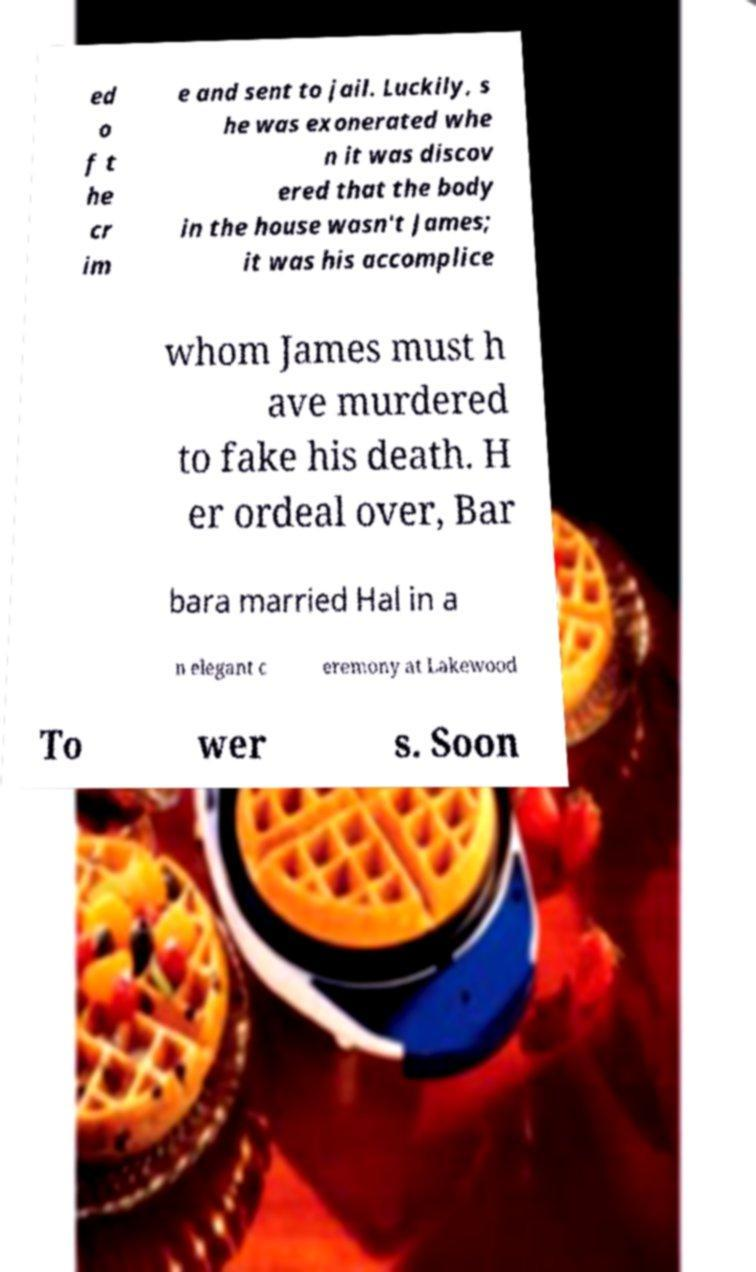Could you extract and type out the text from this image? ed o f t he cr im e and sent to jail. Luckily, s he was exonerated whe n it was discov ered that the body in the house wasn't James; it was his accomplice whom James must h ave murdered to fake his death. H er ordeal over, Bar bara married Hal in a n elegant c eremony at Lakewood To wer s. Soon 